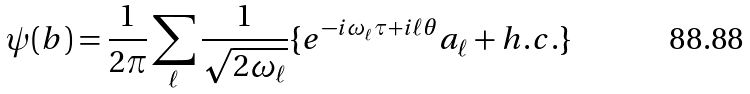<formula> <loc_0><loc_0><loc_500><loc_500>\psi ( b ) = \frac { 1 } { 2 \pi } \sum _ { \ell } \frac { 1 } { \sqrt { 2 \omega _ { \ell } } } \{ e ^ { - i \omega _ { \ell } \tau + i \ell \theta } a _ { \ell } + h . c . \}</formula> 